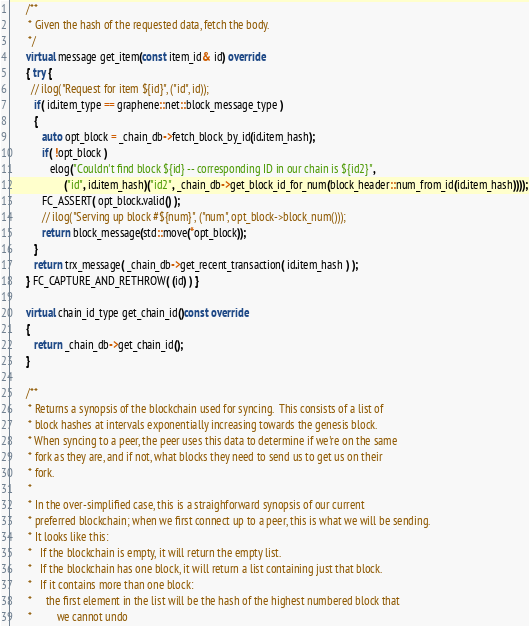<code> <loc_0><loc_0><loc_500><loc_500><_C++_>
      /**
       * Given the hash of the requested data, fetch the body.
       */
      virtual message get_item(const item_id& id) override
      { try {
        // ilog("Request for item ${id}", ("id", id));
         if( id.item_type == graphene::net::block_message_type )
         {
            auto opt_block = _chain_db->fetch_block_by_id(id.item_hash);
            if( !opt_block )
               elog("Couldn't find block ${id} -- corresponding ID in our chain is ${id2}",
                    ("id", id.item_hash)("id2", _chain_db->get_block_id_for_num(block_header::num_from_id(id.item_hash))));
            FC_ASSERT( opt_block.valid() );
            // ilog("Serving up block #${num}", ("num", opt_block->block_num()));
            return block_message(std::move(*opt_block));
         }
         return trx_message( _chain_db->get_recent_transaction( id.item_hash ) );
      } FC_CAPTURE_AND_RETHROW( (id) ) }

      virtual chain_id_type get_chain_id()const override
      {
         return _chain_db->get_chain_id();
      }

      /**
       * Returns a synopsis of the blockchain used for syncing.  This consists of a list of
       * block hashes at intervals exponentially increasing towards the genesis block.
       * When syncing to a peer, the peer uses this data to determine if we're on the same
       * fork as they are, and if not, what blocks they need to send us to get us on their
       * fork.
       *
       * In the over-simplified case, this is a straighforward synopsis of our current
       * preferred blockchain; when we first connect up to a peer, this is what we will be sending.
       * It looks like this:
       *   If the blockchain is empty, it will return the empty list.
       *   If the blockchain has one block, it will return a list containing just that block.
       *   If it contains more than one block:
       *     the first element in the list will be the hash of the highest numbered block that
       *         we cannot undo</code> 